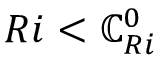<formula> <loc_0><loc_0><loc_500><loc_500>R i < \mathbb { C } _ { R i } ^ { 0 }</formula> 